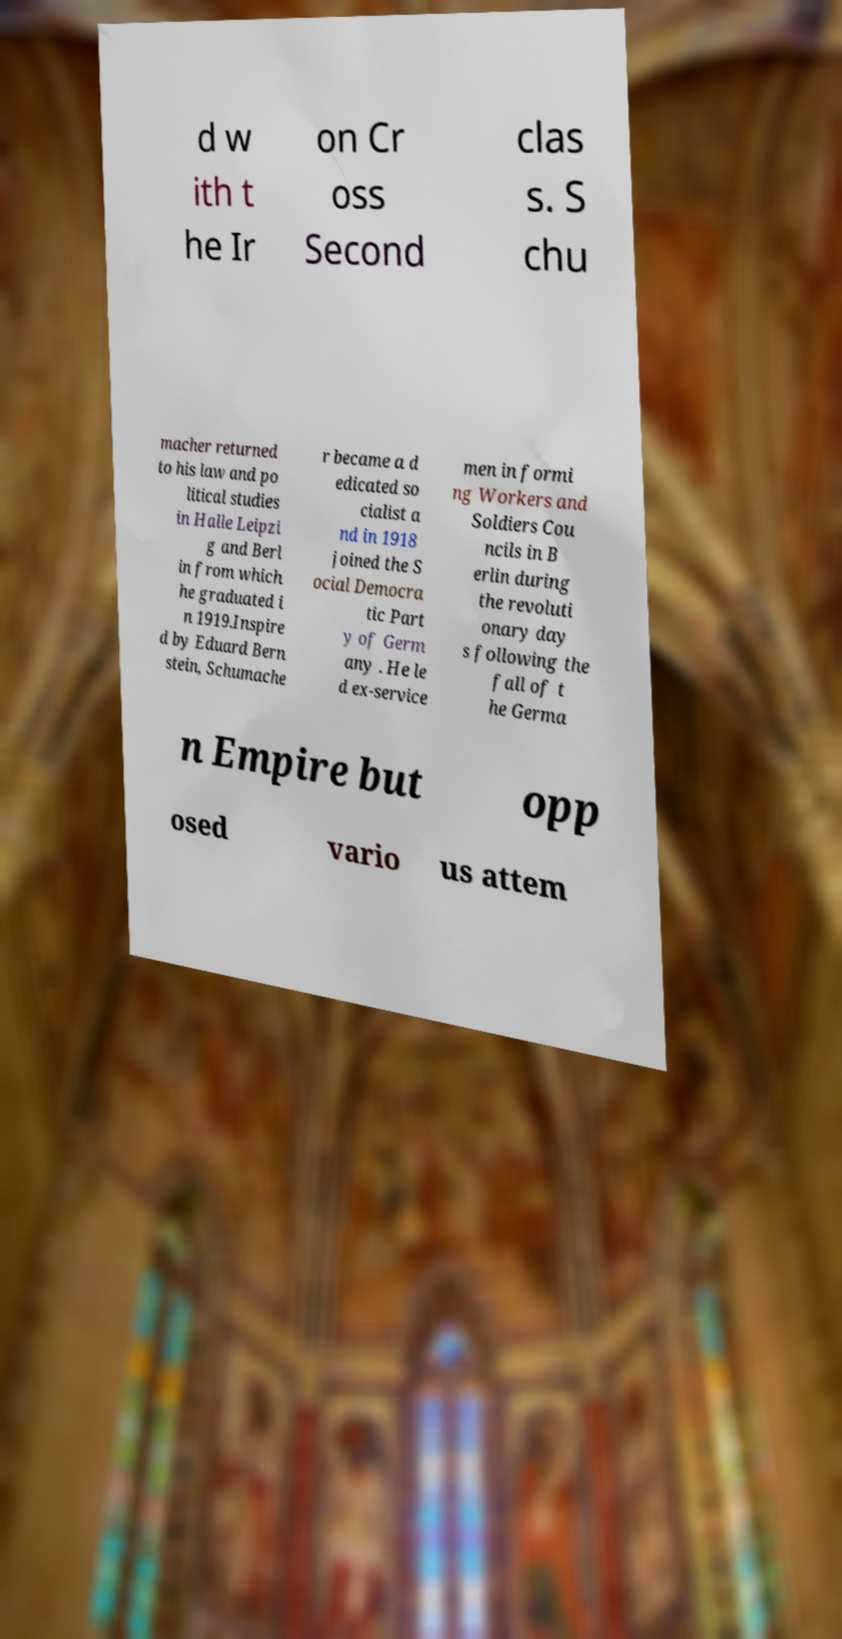Please identify and transcribe the text found in this image. d w ith t he Ir on Cr oss Second clas s. S chu macher returned to his law and po litical studies in Halle Leipzi g and Berl in from which he graduated i n 1919.Inspire d by Eduard Bern stein, Schumache r became a d edicated so cialist a nd in 1918 joined the S ocial Democra tic Part y of Germ any . He le d ex-service men in formi ng Workers and Soldiers Cou ncils in B erlin during the revoluti onary day s following the fall of t he Germa n Empire but opp osed vario us attem 